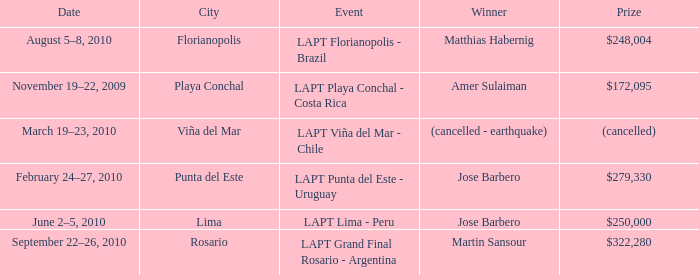What is the date of the event with a $322,280 prize? September 22–26, 2010. 